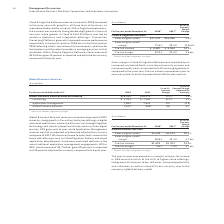According to International Business Machines's financial document, What caused the increase in Global Business Services revenue? Based on the financial document, the answer is driven by strong growth in Consulting, led by key offerings in digital Global Business Services revenue increased compared to 2017 driven by strong growth in Consulting, led by key offerings in digital and cloud application, where the business has brought together technology and industry expertise to help clients on their digital journey. Also, What was the impact on GPS and Application Management revenue? GPS grew year to year, while Application Management revenue was flat as reported and declined adjusted for currency compared to 2017.. The document states: "xpertise to help clients on their digital journey. GPS grew year to year, while Application Management revenue was flat as reported and declined adjus..." Also, What was the percentage growth in GBS Cloud revenue? According to the financial document, 20 percent. The relevant text states: "s. Within GBS, cloud revenue of $4.7 billion grew 20 percent as reported and 19 percent adjusted for currency compared to the prior year...." Also, can you calculate: What is the increase / (decrease) in the Global Business Services external revenue from 2017 to 2018? Based on the calculation: 16,595 - 16,073, the result is 522 (in millions). This is based on the information: "bal Business Services external revenue $16,595 * $16,073 * 3.2% 2.3% Global Business Services external revenue $16,595 * $16,073 * 3.2% 2.3%..." The key data points involved are: 16,073, 16,595. Also, can you calculate: What is the average consulting? To answer this question, I need to perform calculations using the financial data. The calculation is: (7,705 + 7,262) / 2, which equals 7483.5 (in millions). This is based on the information: "Consulting $ 7,705 $ 7,262 6.1% 5.1% Consulting $ 7,705 $ 7,262 6.1% 5.1%..." The key data points involved are: 7,262, 7,705. Also, can you calculate: What percentage of total Global Business Services external revenue was Application Management in 2018? Based on the calculation: 7,705 / 16,595, the result is 46.43 (percentage). This is based on the information: "Consulting $ 7,705 $ 7,262 6.1% 5.1% Global Business Services external revenue $16,595 * $16,073 * 3.2% 2.3%..." The key data points involved are: 16,595, 7,705. 